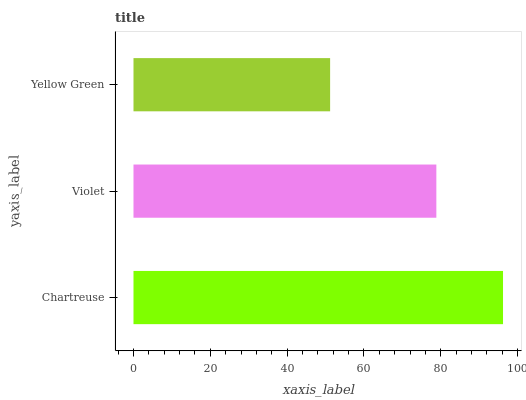Is Yellow Green the minimum?
Answer yes or no. Yes. Is Chartreuse the maximum?
Answer yes or no. Yes. Is Violet the minimum?
Answer yes or no. No. Is Violet the maximum?
Answer yes or no. No. Is Chartreuse greater than Violet?
Answer yes or no. Yes. Is Violet less than Chartreuse?
Answer yes or no. Yes. Is Violet greater than Chartreuse?
Answer yes or no. No. Is Chartreuse less than Violet?
Answer yes or no. No. Is Violet the high median?
Answer yes or no. Yes. Is Violet the low median?
Answer yes or no. Yes. Is Yellow Green the high median?
Answer yes or no. No. Is Chartreuse the low median?
Answer yes or no. No. 